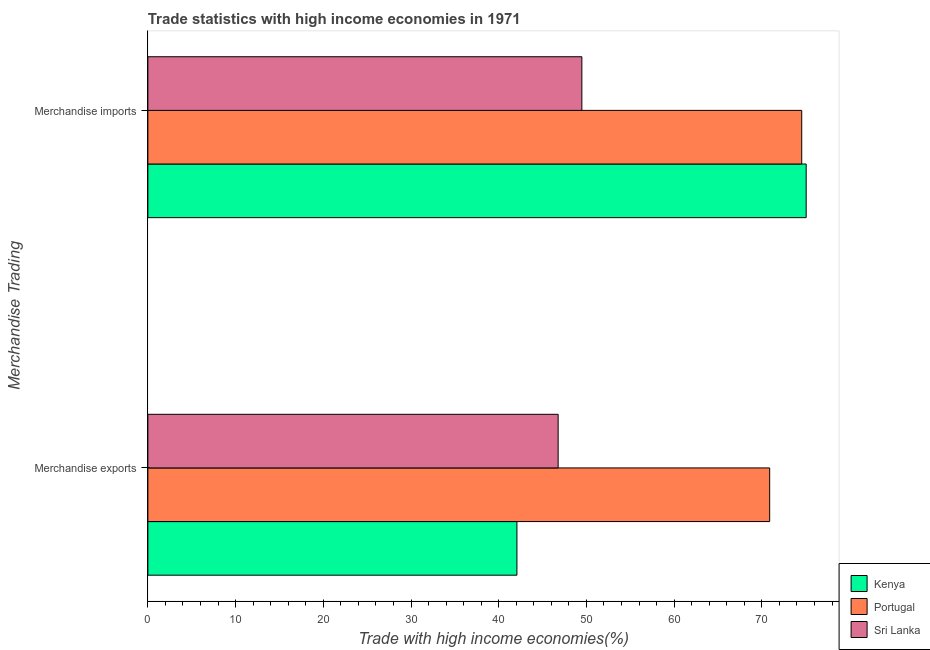Are the number of bars per tick equal to the number of legend labels?
Give a very brief answer. Yes. What is the label of the 2nd group of bars from the top?
Offer a very short reply. Merchandise exports. What is the merchandise exports in Portugal?
Keep it short and to the point. 70.89. Across all countries, what is the maximum merchandise imports?
Offer a terse response. 75.05. Across all countries, what is the minimum merchandise imports?
Offer a terse response. 49.48. In which country was the merchandise imports maximum?
Give a very brief answer. Kenya. In which country was the merchandise imports minimum?
Your answer should be compact. Sri Lanka. What is the total merchandise imports in the graph?
Provide a short and direct response. 199.08. What is the difference between the merchandise imports in Portugal and that in Kenya?
Your answer should be very brief. -0.51. What is the difference between the merchandise exports in Kenya and the merchandise imports in Portugal?
Your answer should be very brief. -32.47. What is the average merchandise exports per country?
Ensure brevity in your answer.  53.25. What is the difference between the merchandise imports and merchandise exports in Portugal?
Keep it short and to the point. 3.65. What is the ratio of the merchandise imports in Kenya to that in Sri Lanka?
Offer a terse response. 1.52. Is the merchandise imports in Kenya less than that in Portugal?
Provide a short and direct response. No. What does the 1st bar from the bottom in Merchandise exports represents?
Make the answer very short. Kenya. How many countries are there in the graph?
Provide a succinct answer. 3. Are the values on the major ticks of X-axis written in scientific E-notation?
Your answer should be compact. No. Does the graph contain any zero values?
Provide a short and direct response. No. Does the graph contain grids?
Give a very brief answer. No. How many legend labels are there?
Your answer should be compact. 3. How are the legend labels stacked?
Ensure brevity in your answer.  Vertical. What is the title of the graph?
Your answer should be compact. Trade statistics with high income economies in 1971. What is the label or title of the X-axis?
Your answer should be compact. Trade with high income economies(%). What is the label or title of the Y-axis?
Provide a succinct answer. Merchandise Trading. What is the Trade with high income economies(%) of Kenya in Merchandise exports?
Give a very brief answer. 42.08. What is the Trade with high income economies(%) of Portugal in Merchandise exports?
Give a very brief answer. 70.89. What is the Trade with high income economies(%) in Sri Lanka in Merchandise exports?
Offer a terse response. 46.78. What is the Trade with high income economies(%) of Kenya in Merchandise imports?
Keep it short and to the point. 75.05. What is the Trade with high income economies(%) of Portugal in Merchandise imports?
Keep it short and to the point. 74.54. What is the Trade with high income economies(%) in Sri Lanka in Merchandise imports?
Your answer should be very brief. 49.48. Across all Merchandise Trading, what is the maximum Trade with high income economies(%) in Kenya?
Provide a succinct answer. 75.05. Across all Merchandise Trading, what is the maximum Trade with high income economies(%) in Portugal?
Provide a succinct answer. 74.54. Across all Merchandise Trading, what is the maximum Trade with high income economies(%) in Sri Lanka?
Make the answer very short. 49.48. Across all Merchandise Trading, what is the minimum Trade with high income economies(%) in Kenya?
Give a very brief answer. 42.08. Across all Merchandise Trading, what is the minimum Trade with high income economies(%) in Portugal?
Your response must be concise. 70.89. Across all Merchandise Trading, what is the minimum Trade with high income economies(%) of Sri Lanka?
Your answer should be compact. 46.78. What is the total Trade with high income economies(%) in Kenya in the graph?
Keep it short and to the point. 117.13. What is the total Trade with high income economies(%) in Portugal in the graph?
Ensure brevity in your answer.  145.44. What is the total Trade with high income economies(%) in Sri Lanka in the graph?
Provide a short and direct response. 96.25. What is the difference between the Trade with high income economies(%) in Kenya in Merchandise exports and that in Merchandise imports?
Your response must be concise. -32.98. What is the difference between the Trade with high income economies(%) of Portugal in Merchandise exports and that in Merchandise imports?
Offer a terse response. -3.65. What is the difference between the Trade with high income economies(%) of Sri Lanka in Merchandise exports and that in Merchandise imports?
Provide a short and direct response. -2.7. What is the difference between the Trade with high income economies(%) in Kenya in Merchandise exports and the Trade with high income economies(%) in Portugal in Merchandise imports?
Offer a terse response. -32.47. What is the difference between the Trade with high income economies(%) in Kenya in Merchandise exports and the Trade with high income economies(%) in Sri Lanka in Merchandise imports?
Your answer should be compact. -7.4. What is the difference between the Trade with high income economies(%) of Portugal in Merchandise exports and the Trade with high income economies(%) of Sri Lanka in Merchandise imports?
Offer a very short reply. 21.41. What is the average Trade with high income economies(%) in Kenya per Merchandise Trading?
Provide a short and direct response. 58.56. What is the average Trade with high income economies(%) in Portugal per Merchandise Trading?
Your response must be concise. 72.72. What is the average Trade with high income economies(%) of Sri Lanka per Merchandise Trading?
Offer a terse response. 48.13. What is the difference between the Trade with high income economies(%) in Kenya and Trade with high income economies(%) in Portugal in Merchandise exports?
Provide a succinct answer. -28.81. What is the difference between the Trade with high income economies(%) of Kenya and Trade with high income economies(%) of Sri Lanka in Merchandise exports?
Offer a very short reply. -4.7. What is the difference between the Trade with high income economies(%) in Portugal and Trade with high income economies(%) in Sri Lanka in Merchandise exports?
Offer a terse response. 24.12. What is the difference between the Trade with high income economies(%) in Kenya and Trade with high income economies(%) in Portugal in Merchandise imports?
Your answer should be very brief. 0.51. What is the difference between the Trade with high income economies(%) of Kenya and Trade with high income economies(%) of Sri Lanka in Merchandise imports?
Offer a terse response. 25.57. What is the difference between the Trade with high income economies(%) of Portugal and Trade with high income economies(%) of Sri Lanka in Merchandise imports?
Keep it short and to the point. 25.07. What is the ratio of the Trade with high income economies(%) of Kenya in Merchandise exports to that in Merchandise imports?
Offer a very short reply. 0.56. What is the ratio of the Trade with high income economies(%) of Portugal in Merchandise exports to that in Merchandise imports?
Provide a short and direct response. 0.95. What is the ratio of the Trade with high income economies(%) in Sri Lanka in Merchandise exports to that in Merchandise imports?
Give a very brief answer. 0.95. What is the difference between the highest and the second highest Trade with high income economies(%) of Kenya?
Offer a terse response. 32.98. What is the difference between the highest and the second highest Trade with high income economies(%) in Portugal?
Keep it short and to the point. 3.65. What is the difference between the highest and the second highest Trade with high income economies(%) of Sri Lanka?
Your answer should be very brief. 2.7. What is the difference between the highest and the lowest Trade with high income economies(%) in Kenya?
Give a very brief answer. 32.98. What is the difference between the highest and the lowest Trade with high income economies(%) in Portugal?
Keep it short and to the point. 3.65. What is the difference between the highest and the lowest Trade with high income economies(%) of Sri Lanka?
Offer a terse response. 2.7. 